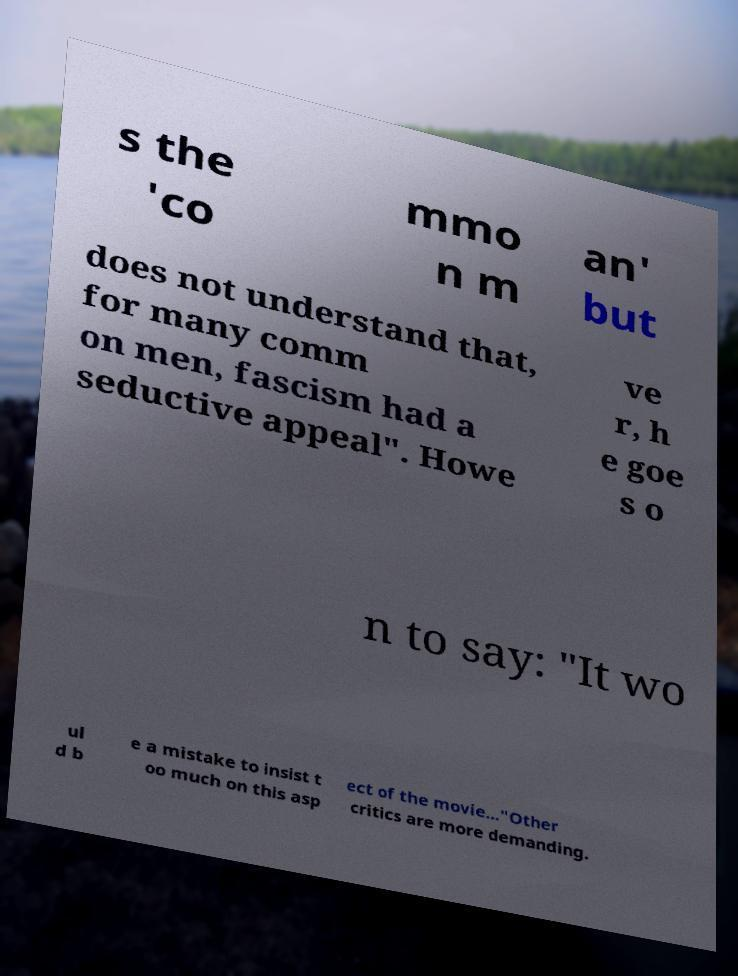What messages or text are displayed in this image? I need them in a readable, typed format. s the 'co mmo n m an' but does not understand that, for many comm on men, fascism had a seductive appeal". Howe ve r, h e goe s o n to say: "It wo ul d b e a mistake to insist t oo much on this asp ect of the movie..."Other critics are more demanding. 